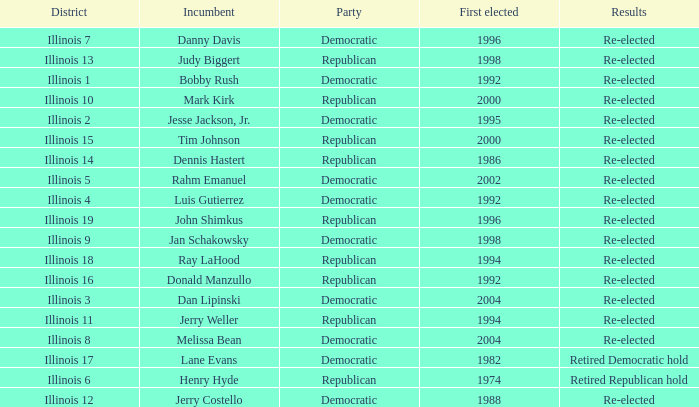What is the Party of District of Illinois 19 with an Incumbent First elected in 1996? Republican. 